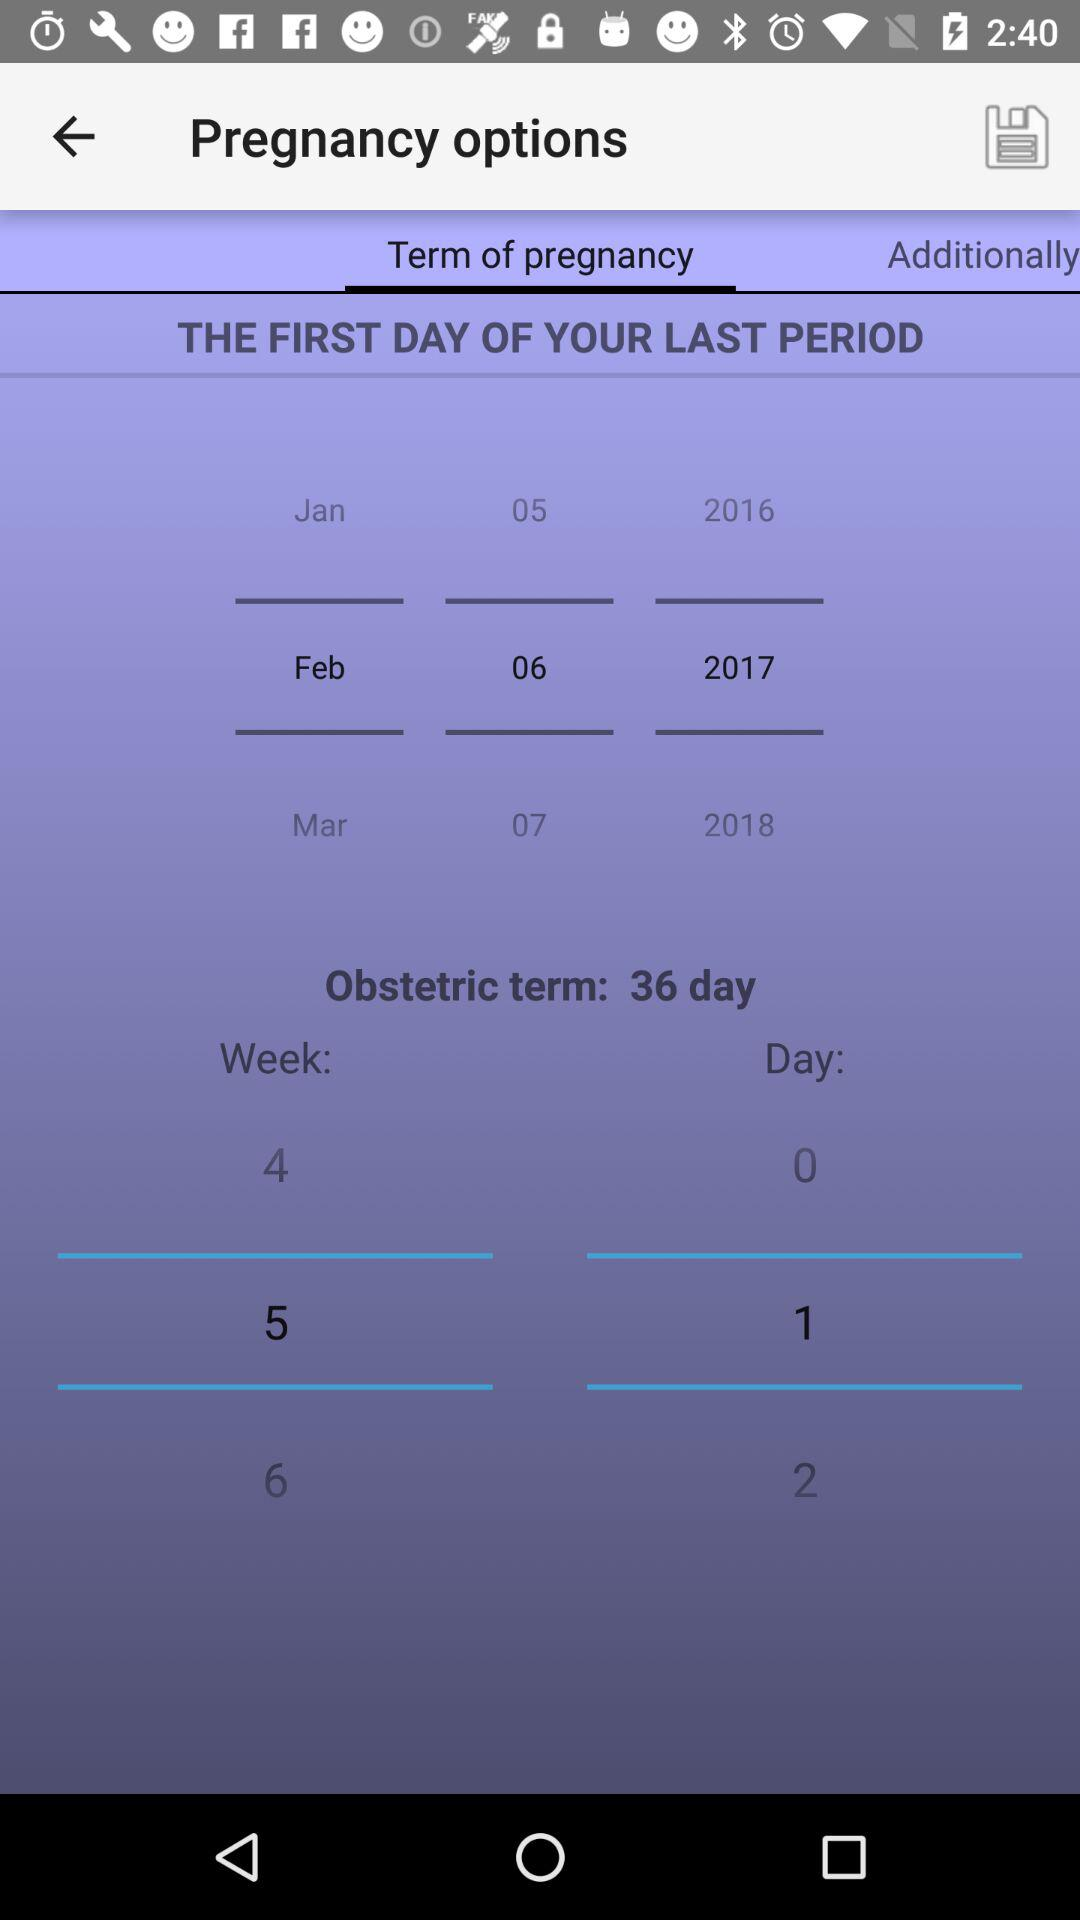What is the first day of last period? The first day of the last period is February 06, 2017. 